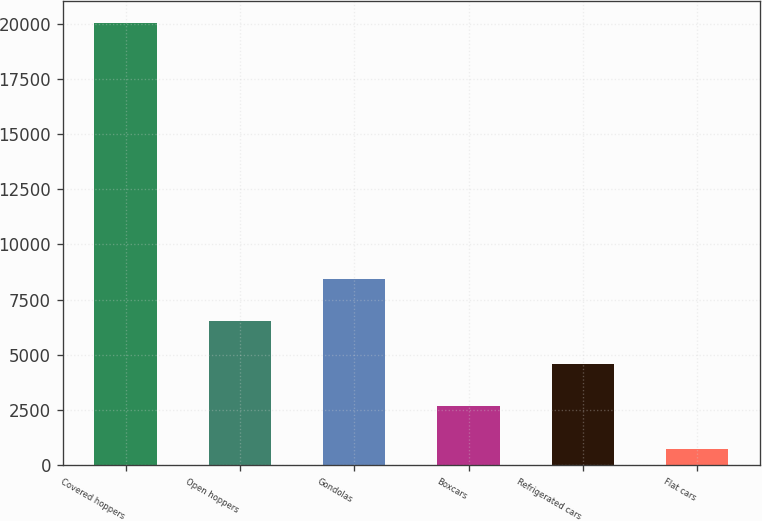<chart> <loc_0><loc_0><loc_500><loc_500><bar_chart><fcel>Covered hoppers<fcel>Open hoppers<fcel>Gondolas<fcel>Boxcars<fcel>Refrigerated cars<fcel>Flat cars<nl><fcel>20024<fcel>6521<fcel>8450<fcel>2663<fcel>4592<fcel>734<nl></chart> 